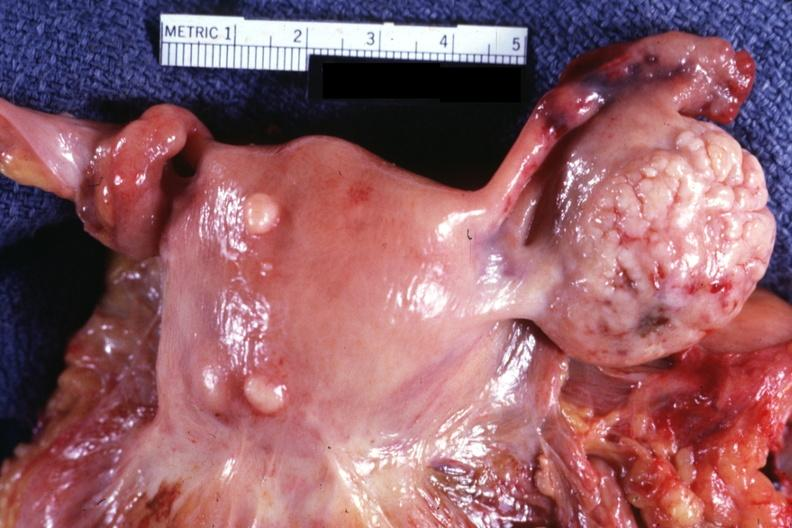s anencephaly present?
Answer the question using a single word or phrase. No 